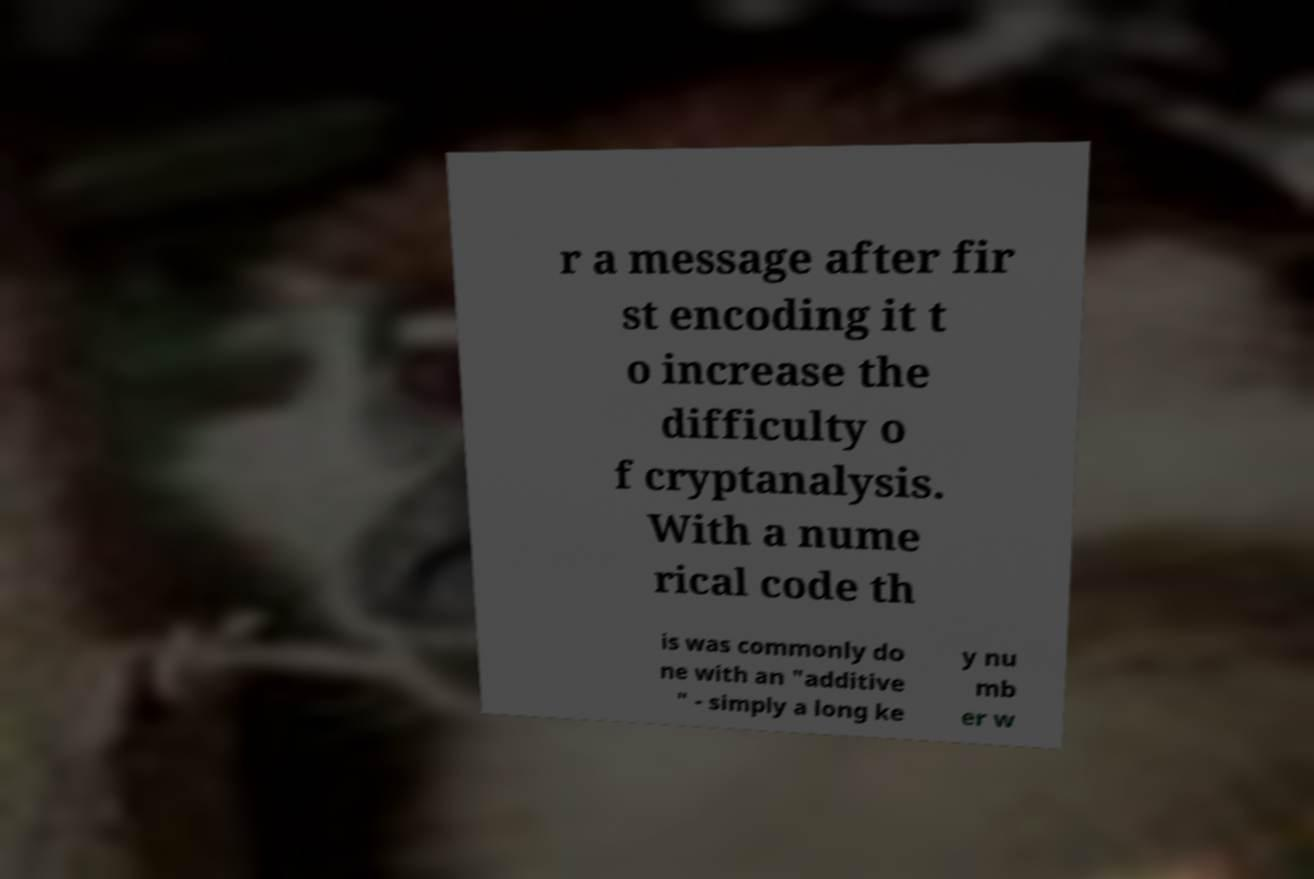Please read and relay the text visible in this image. What does it say? r a message after fir st encoding it t o increase the difficulty o f cryptanalysis. With a nume rical code th is was commonly do ne with an "additive " - simply a long ke y nu mb er w 